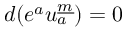<formula> <loc_0><loc_0><loc_500><loc_500>d ( e ^ { a } u _ { a } ^ { \underline { m } } ) = 0</formula> 